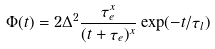<formula> <loc_0><loc_0><loc_500><loc_500>\Phi ( t ) = 2 \Delta ^ { 2 } \frac { \tau _ { e } ^ { x } } { ( t + \tau _ { e } ) ^ { x } } \exp ( - t / \tau _ { l } )</formula> 